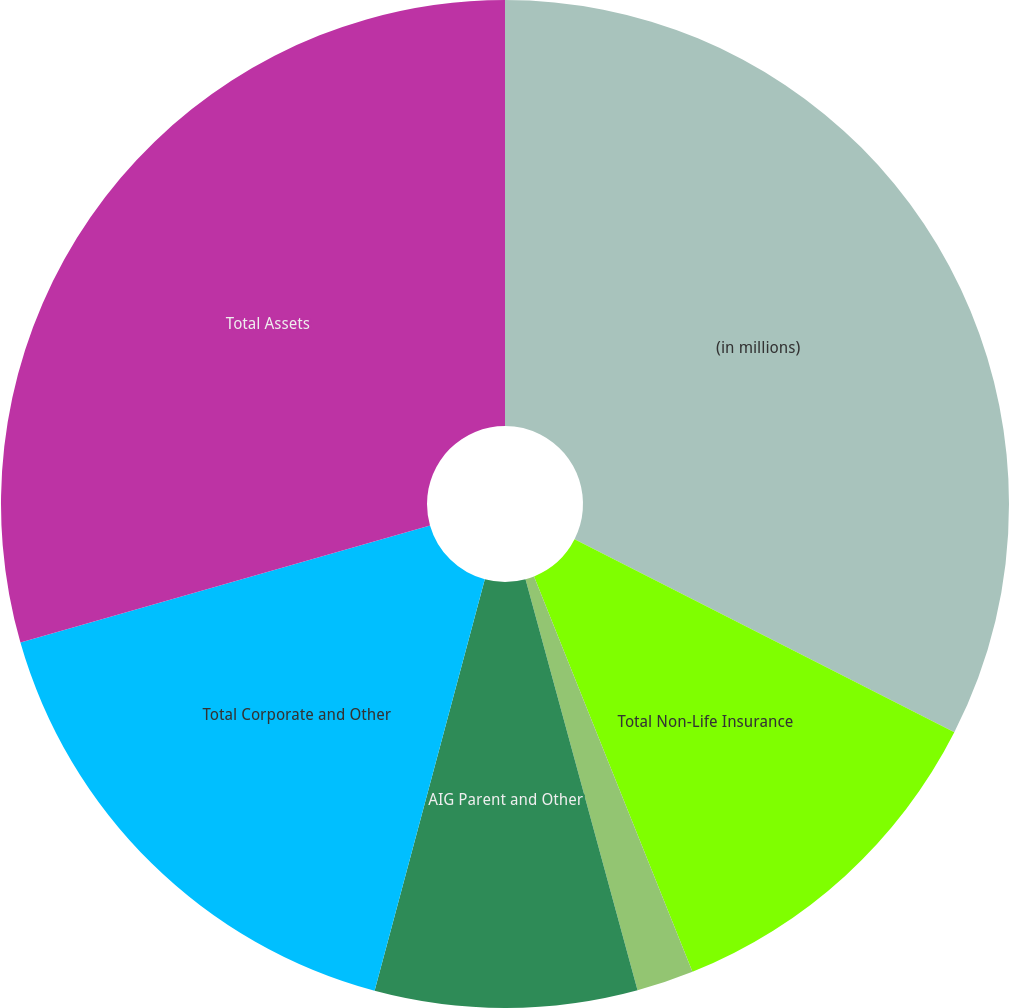Convert chart. <chart><loc_0><loc_0><loc_500><loc_500><pie_chart><fcel>(in millions)<fcel>Total Non-Life Insurance<fcel>Total Life Insurance Companies<fcel>AIG Parent and Other<fcel>Total Corporate and Other<fcel>Total Assets<nl><fcel>32.48%<fcel>11.45%<fcel>1.83%<fcel>8.4%<fcel>16.4%<fcel>29.43%<nl></chart> 